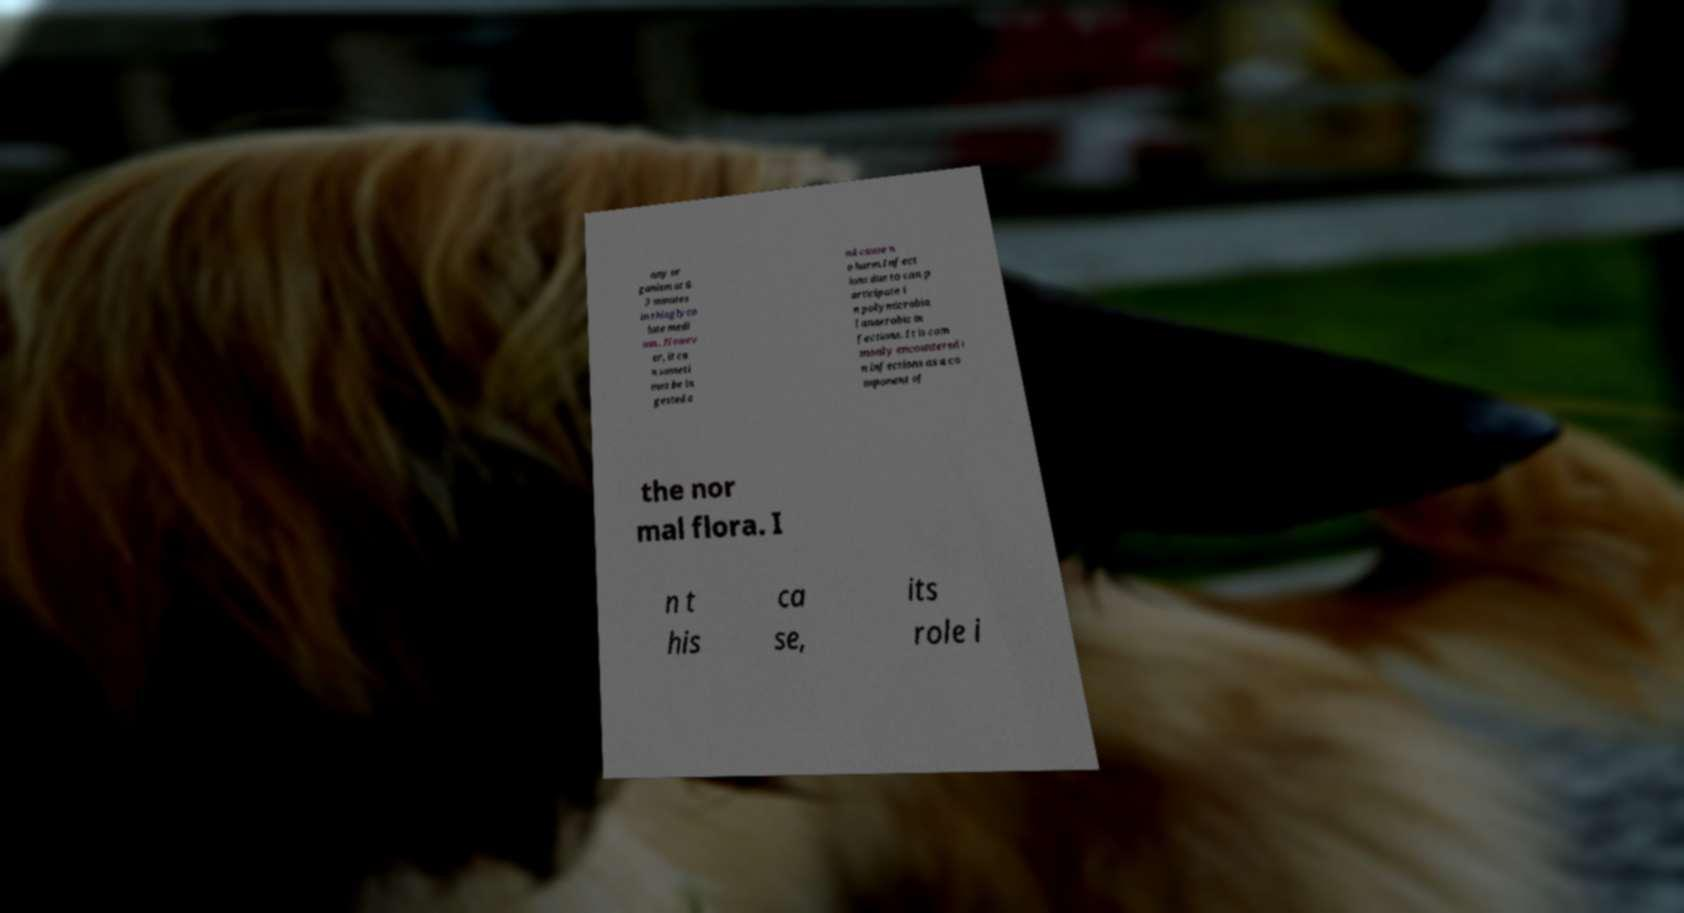Can you accurately transcribe the text from the provided image for me? any or ganism at 6. 3 minutes in thioglyco late medi um.. Howev er, it ca n someti mes be in gested a nd cause n o harm.Infect ions due to can p articipate i n polymicrobia l anaerobic in fections. It is com monly encountered i n infections as a co mponent of the nor mal flora. I n t his ca se, its role i 